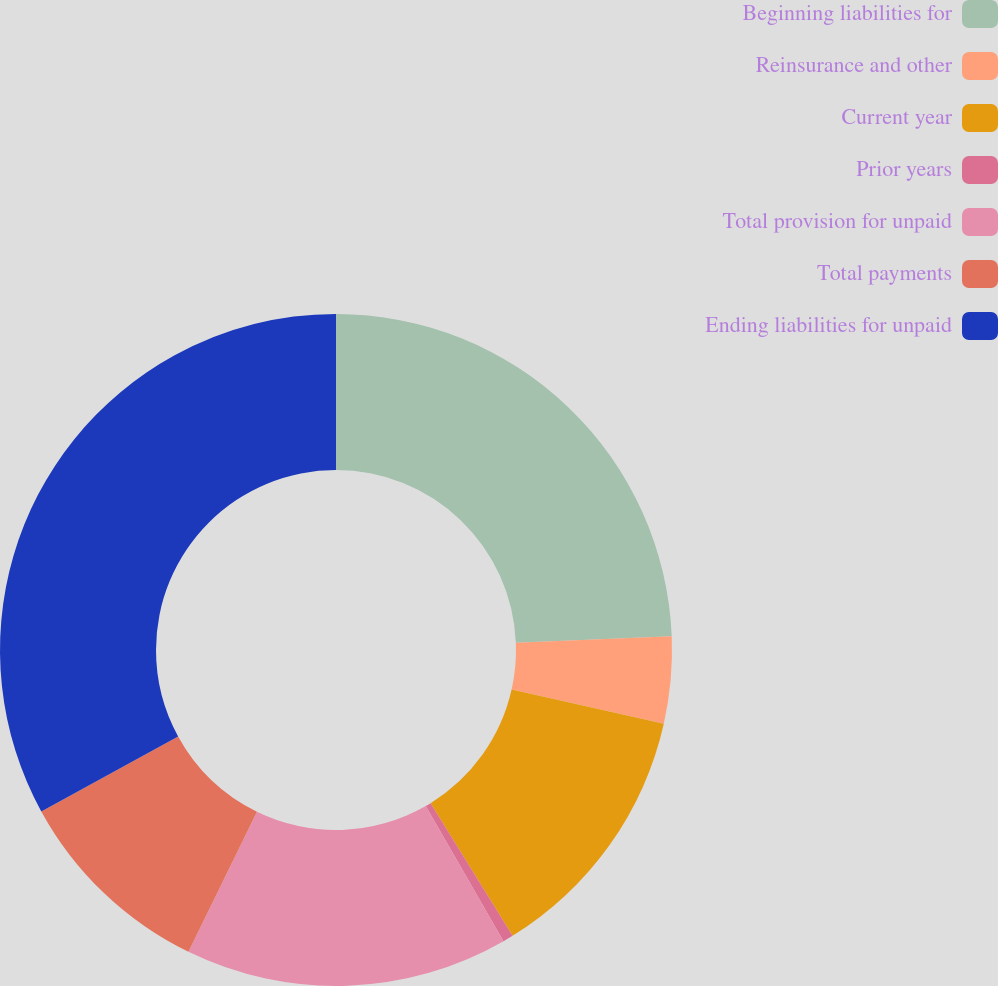<chart> <loc_0><loc_0><loc_500><loc_500><pie_chart><fcel>Beginning liabilities for<fcel>Reinsurance and other<fcel>Current year<fcel>Prior years<fcel>Total provision for unpaid<fcel>Total payments<fcel>Ending liabilities for unpaid<nl><fcel>24.35%<fcel>4.17%<fcel>12.67%<fcel>0.5%<fcel>15.54%<fcel>9.79%<fcel>32.97%<nl></chart> 